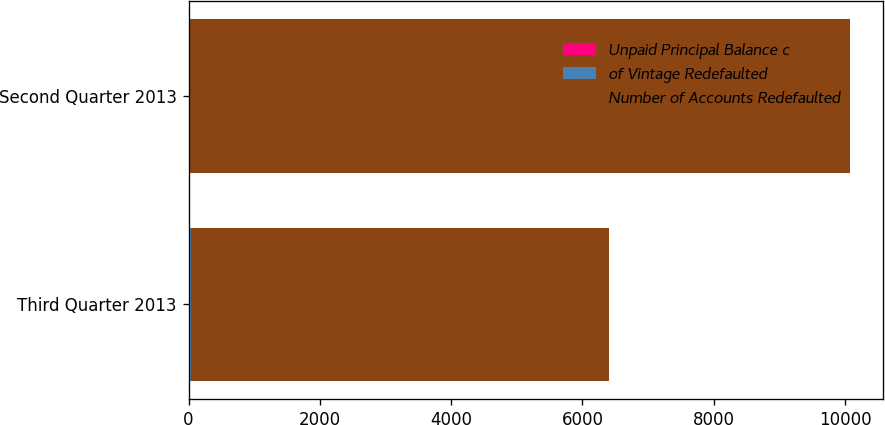Convert chart to OTSL. <chart><loc_0><loc_0><loc_500><loc_500><stacked_bar_chart><ecel><fcel>Third Quarter 2013<fcel>Second Quarter 2013<nl><fcel>Unpaid Principal Balance c<fcel>30<fcel>25<nl><fcel>of Vintage Redefaulted<fcel>2.6<fcel>2<nl><fcel>Number of Accounts Redefaulted<fcel>6376<fcel>10046<nl></chart> 